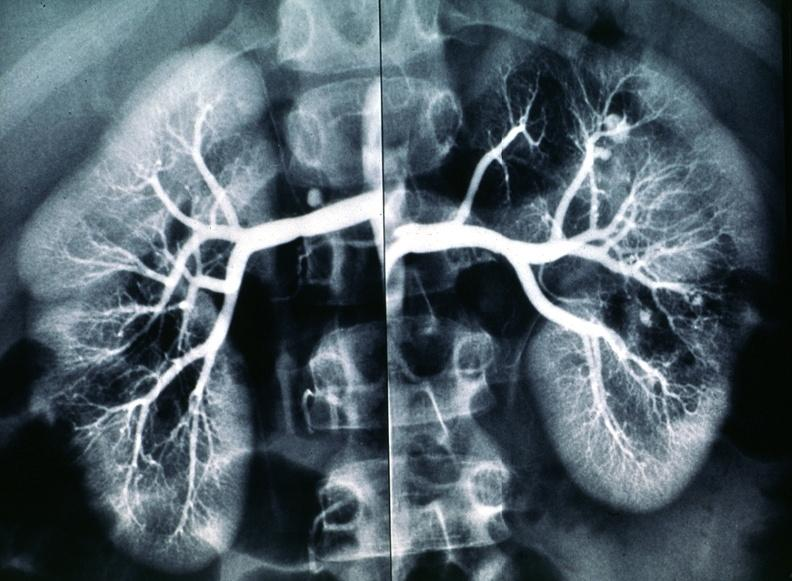what does this image show?
Answer the question using a single word or phrase. Polyarteritis nodosa 